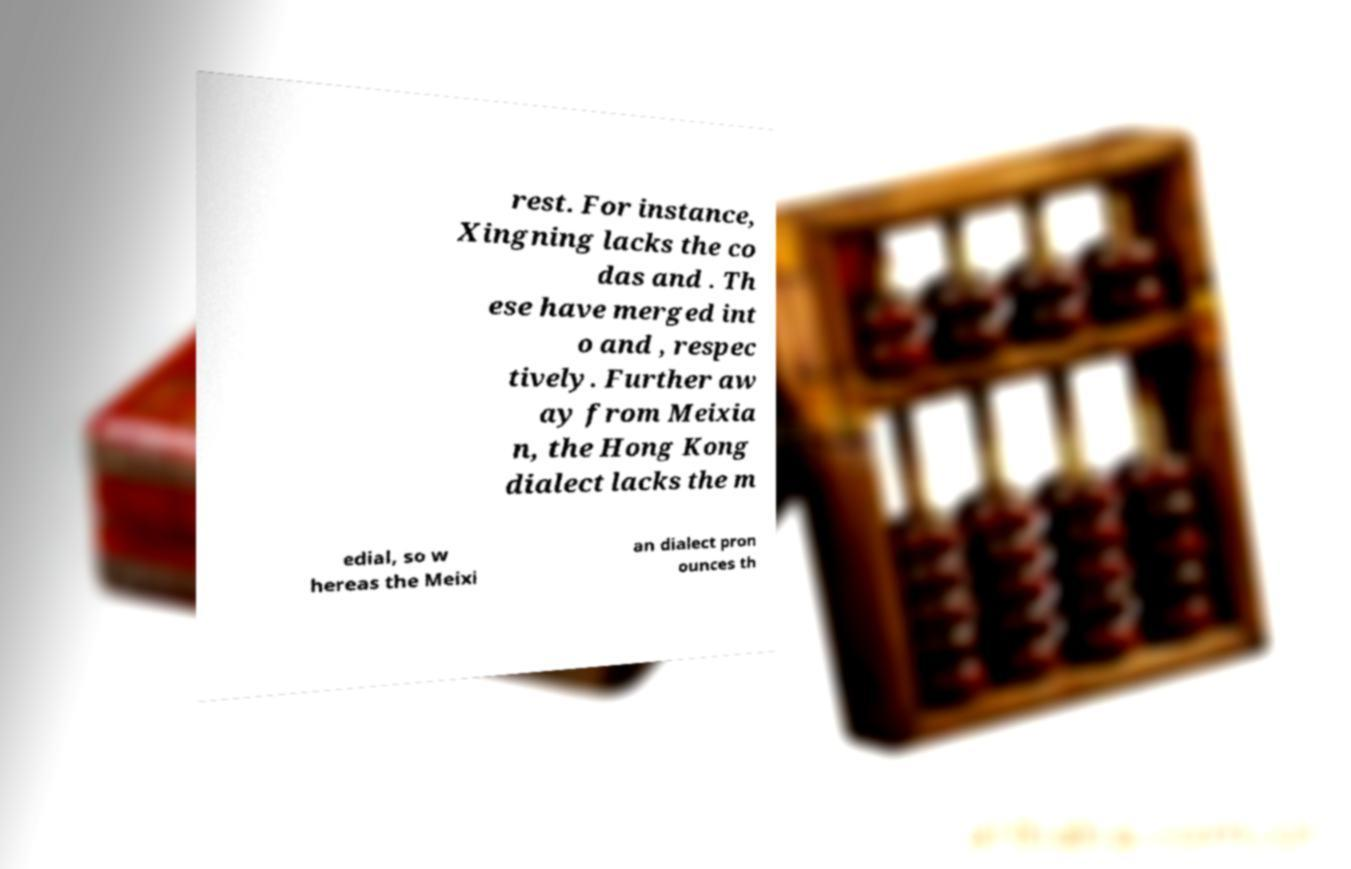Could you extract and type out the text from this image? rest. For instance, Xingning lacks the co das and . Th ese have merged int o and , respec tively. Further aw ay from Meixia n, the Hong Kong dialect lacks the m edial, so w hereas the Meixi an dialect pron ounces th 